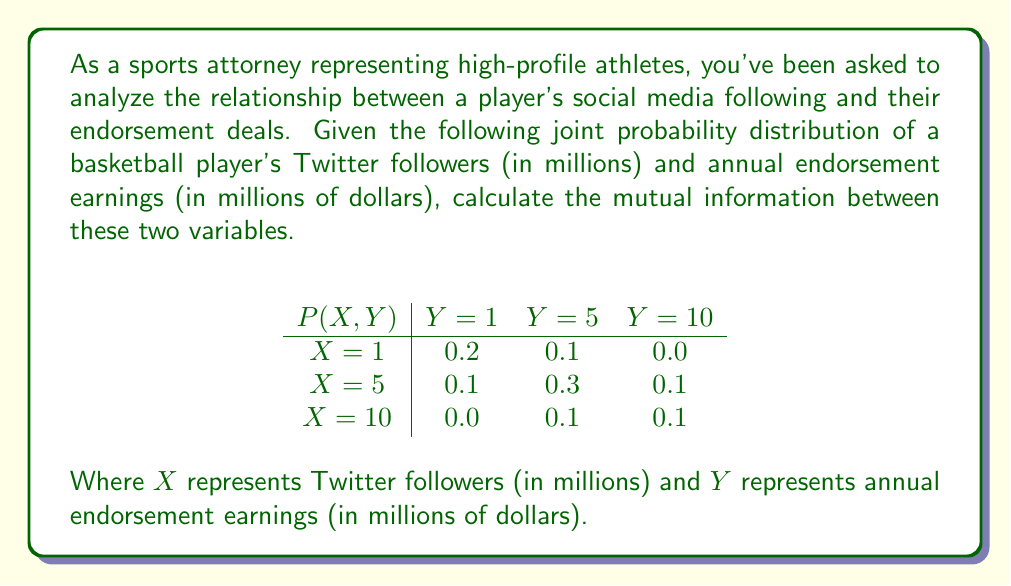Teach me how to tackle this problem. To calculate the mutual information between two variables, we use the formula:

$$ I(X;Y) = \sum_{x \in X} \sum_{y \in Y} p(x,y) \log_2 \left(\frac{p(x,y)}{p(x)p(y)}\right) $$

Step 1: Calculate marginal probabilities $p(x)$ and $p(y)$

For $p(x)$:
$p(X=1) = 0.2 + 0.1 + 0.0 = 0.3$
$p(X=5) = 0.1 + 0.3 + 0.1 = 0.5$
$p(X=10) = 0.0 + 0.1 + 0.1 = 0.2$

For $p(y)$:
$p(Y=1) = 0.2 + 0.1 + 0.0 = 0.3$
$p(Y=5) = 0.1 + 0.3 + 0.1 = 0.5$
$p(Y=10) = 0.0 + 0.1 + 0.1 = 0.2$

Step 2: Calculate $\frac{p(x,y)}{p(x)p(y)}$ for each combination

For example, when $X=1$ and $Y=1$:
$\frac{p(1,1)}{p(1)p(1)} = \frac{0.2}{0.3 \times 0.3} \approx 2.22$

Step 3: Calculate $p(x,y) \log_2 \left(\frac{p(x,y)}{p(x)p(y)}\right)$ for each combination

For $X=1$ and $Y=1$:
$0.2 \log_2(2.22) \approx 0.2259$

Step 4: Sum all values from Step 3

$I(X;Y) = 0.2259 + 0.0 + 0.0 + 0.0 + 0.1204 + 0.0 + 0.0 + 0.0 + 0.1204 = 0.4667$
Answer: The mutual information between the player's Twitter followers and annual endorsement earnings is approximately 0.4667 bits. 